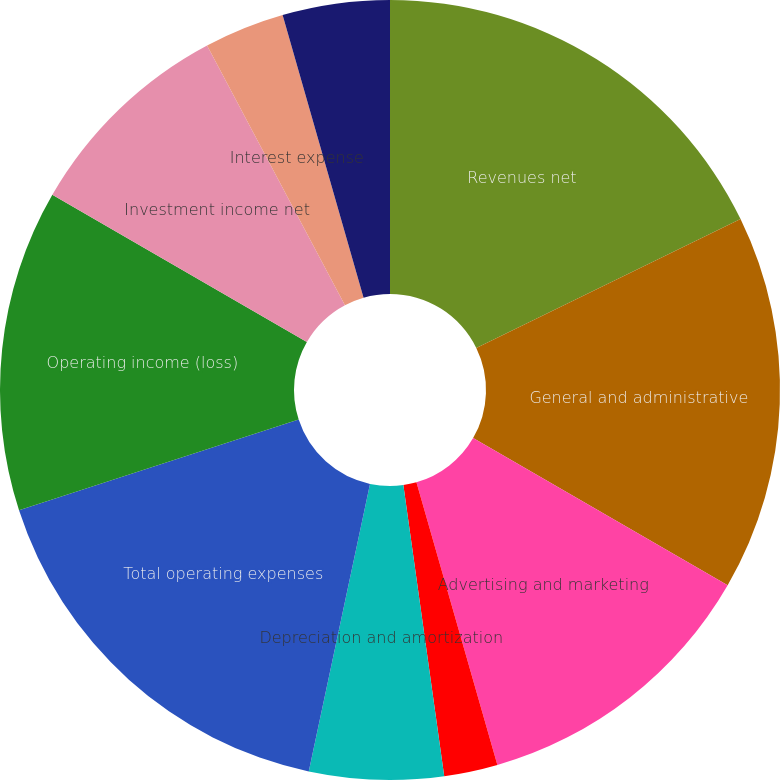Convert chart. <chart><loc_0><loc_0><loc_500><loc_500><pie_chart><fcel>Revenues net<fcel>General and administrative<fcel>Advertising and marketing<fcel>Litigation settlements<fcel>Depreciation and amortization<fcel>Total operating expenses<fcel>Operating income (loss)<fcel>Investment income net<fcel>Interest expense<fcel>Other income (expense) net<nl><fcel>17.78%<fcel>15.56%<fcel>12.22%<fcel>2.22%<fcel>5.56%<fcel>16.67%<fcel>13.33%<fcel>8.89%<fcel>3.33%<fcel>4.44%<nl></chart> 